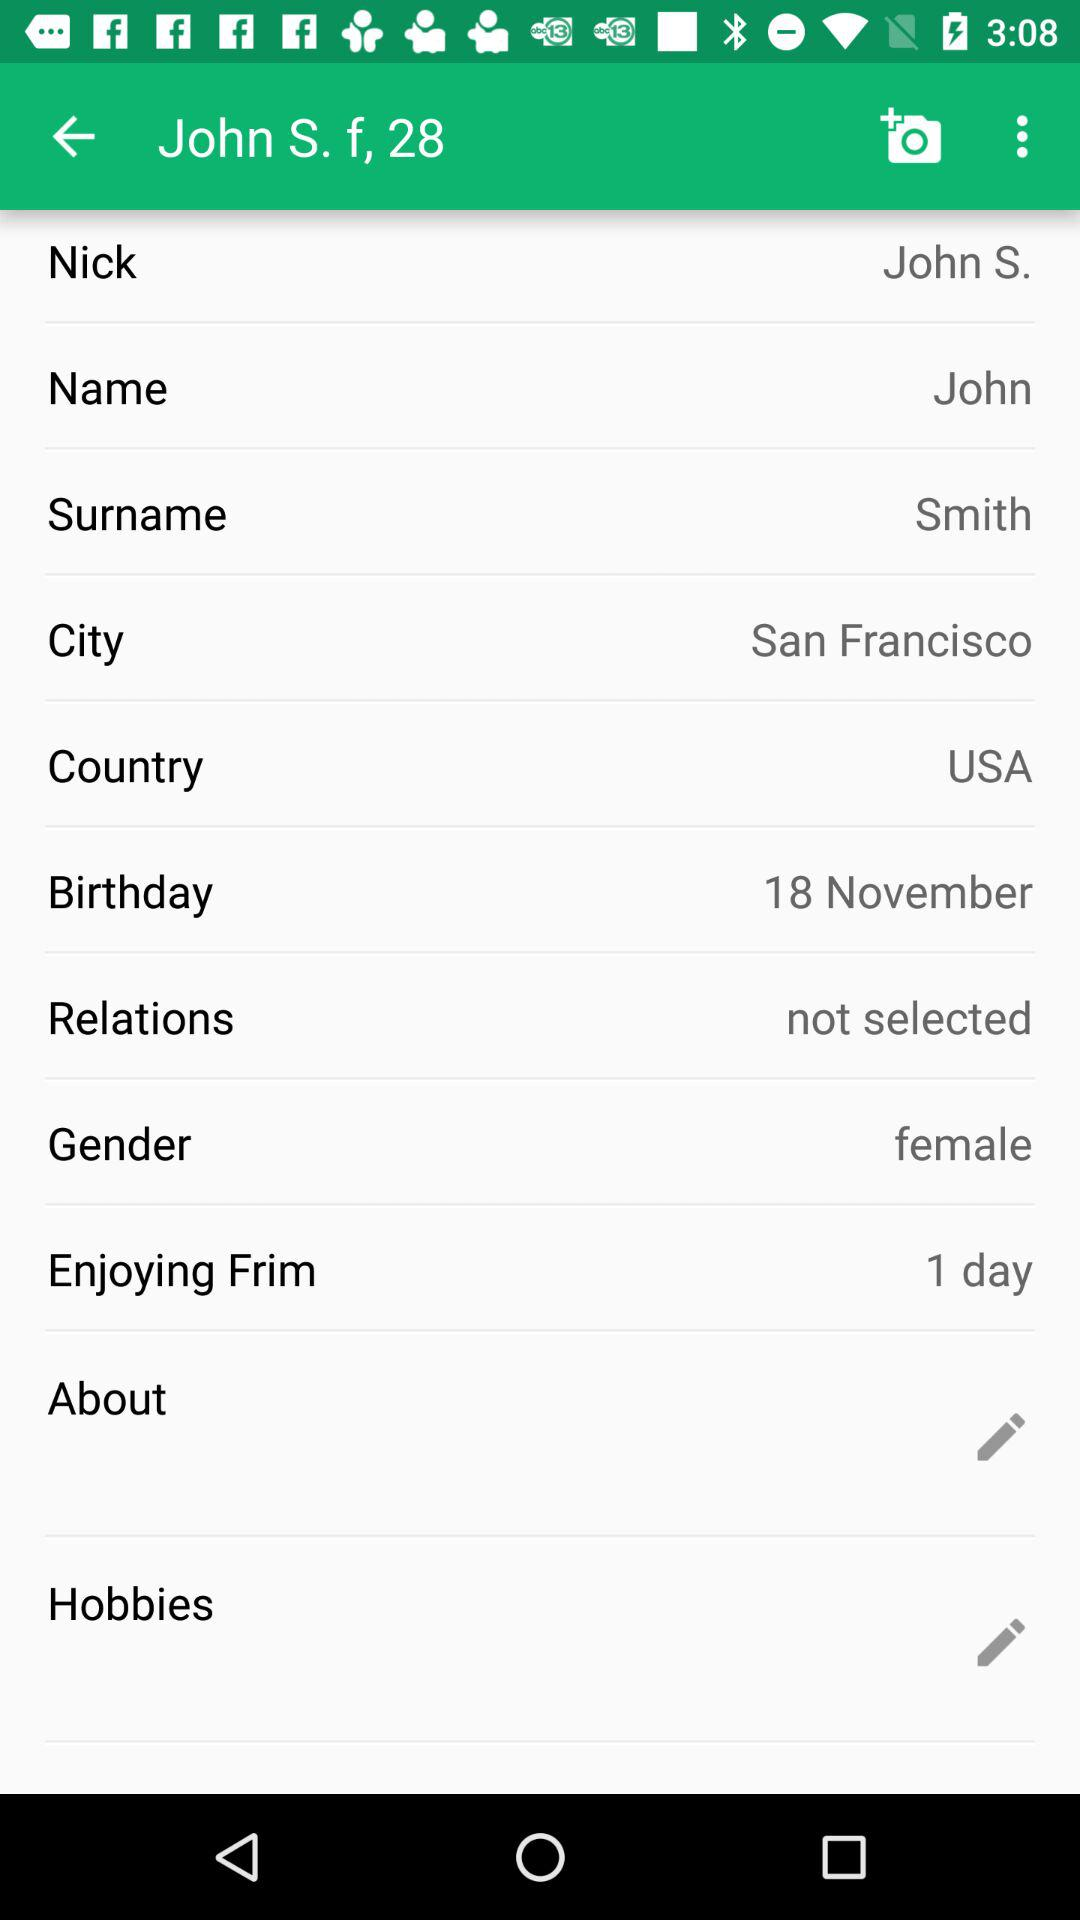What is the given birthdate? The given birthdate is November 18. 